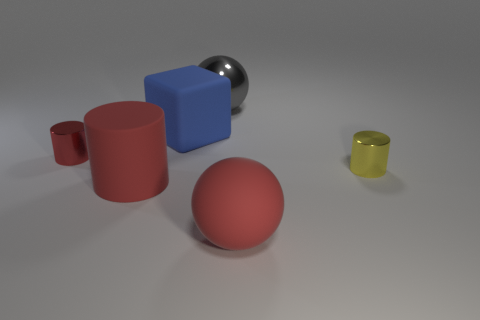Add 1 blue rubber cubes. How many objects exist? 7 Subtract all tiny cylinders. How many cylinders are left? 1 Subtract all spheres. How many objects are left? 4 Subtract 0 green blocks. How many objects are left? 6 Subtract 3 cylinders. How many cylinders are left? 0 Subtract all green cubes. Subtract all red cylinders. How many cubes are left? 1 Subtract all red balls. How many yellow blocks are left? 0 Subtract all red objects. Subtract all cubes. How many objects are left? 2 Add 4 cylinders. How many cylinders are left? 7 Add 6 red cylinders. How many red cylinders exist? 8 